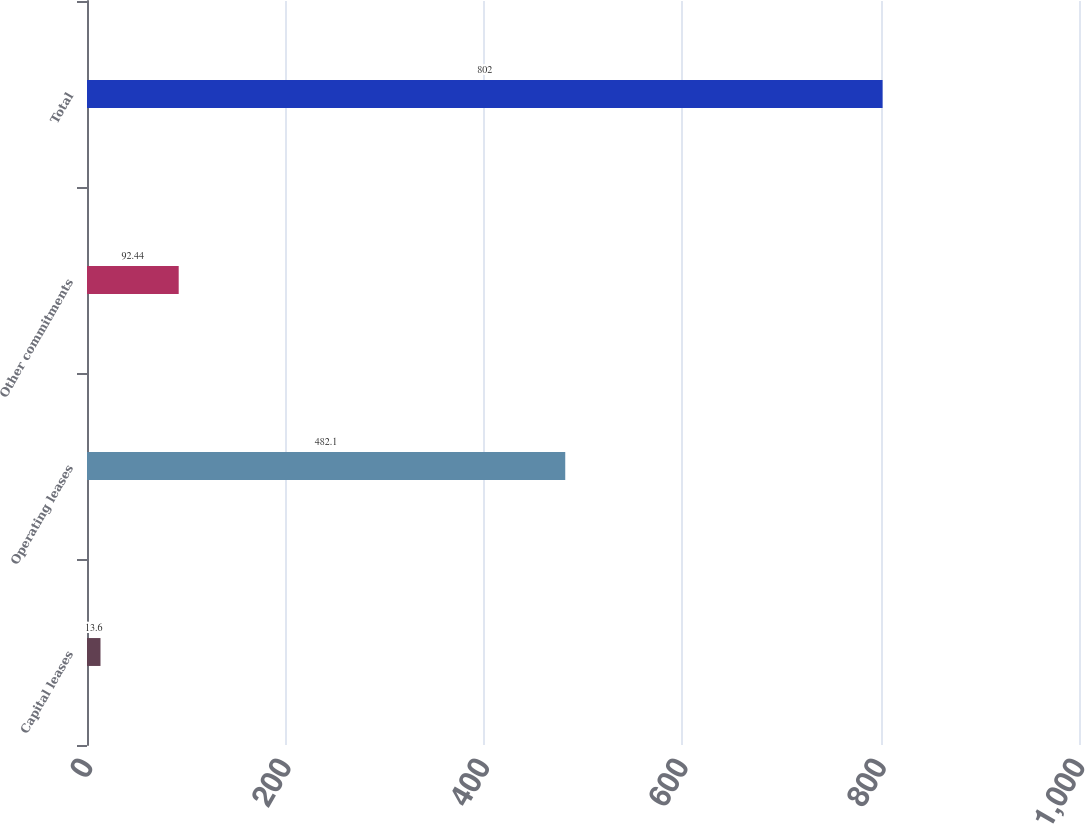Convert chart. <chart><loc_0><loc_0><loc_500><loc_500><bar_chart><fcel>Capital leases<fcel>Operating leases<fcel>Other commitments<fcel>Total<nl><fcel>13.6<fcel>482.1<fcel>92.44<fcel>802<nl></chart> 